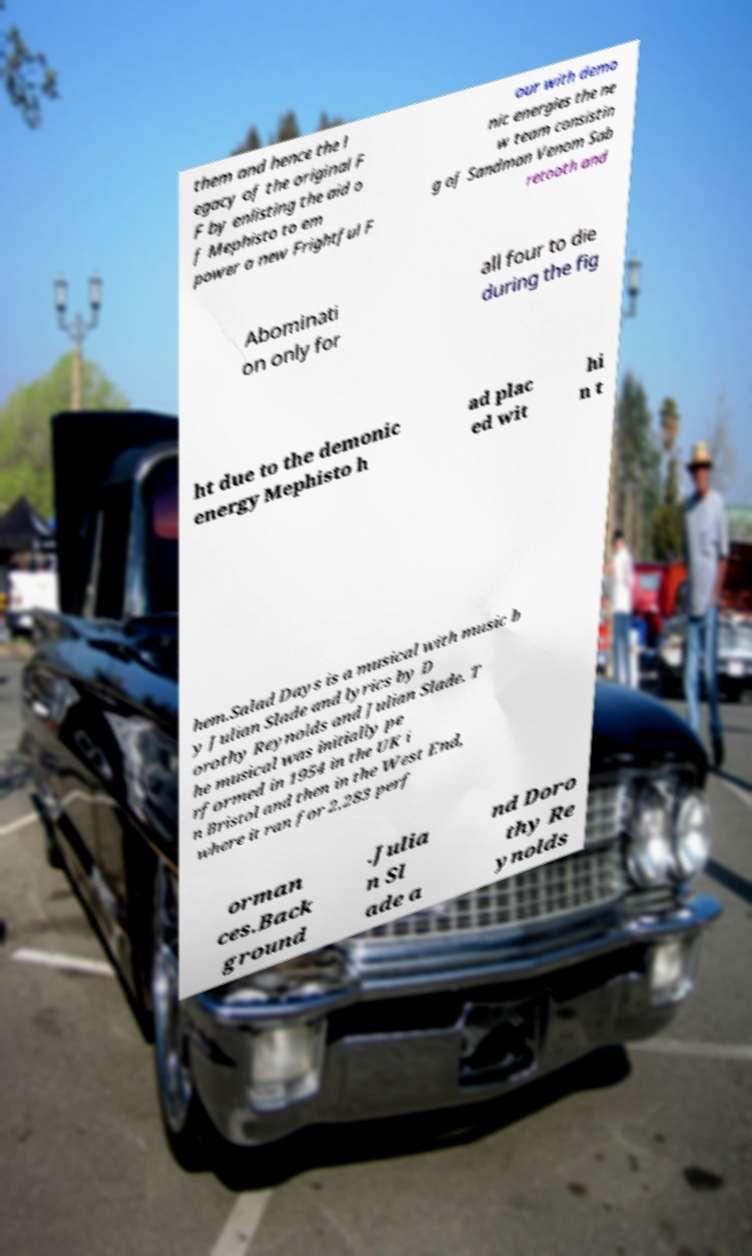Can you accurately transcribe the text from the provided image for me? them and hence the l egacy of the original F F by enlisting the aid o f Mephisto to em power a new Frightful F our with demo nic energies the ne w team consistin g of Sandman Venom Sab retooth and Abominati on only for all four to die during the fig ht due to the demonic energy Mephisto h ad plac ed wit hi n t hem.Salad Days is a musical with music b y Julian Slade and lyrics by D orothy Reynolds and Julian Slade. T he musical was initially pe rformed in 1954 in the UK i n Bristol and then in the West End, where it ran for 2,283 perf orman ces.Back ground .Julia n Sl ade a nd Doro thy Re ynolds 